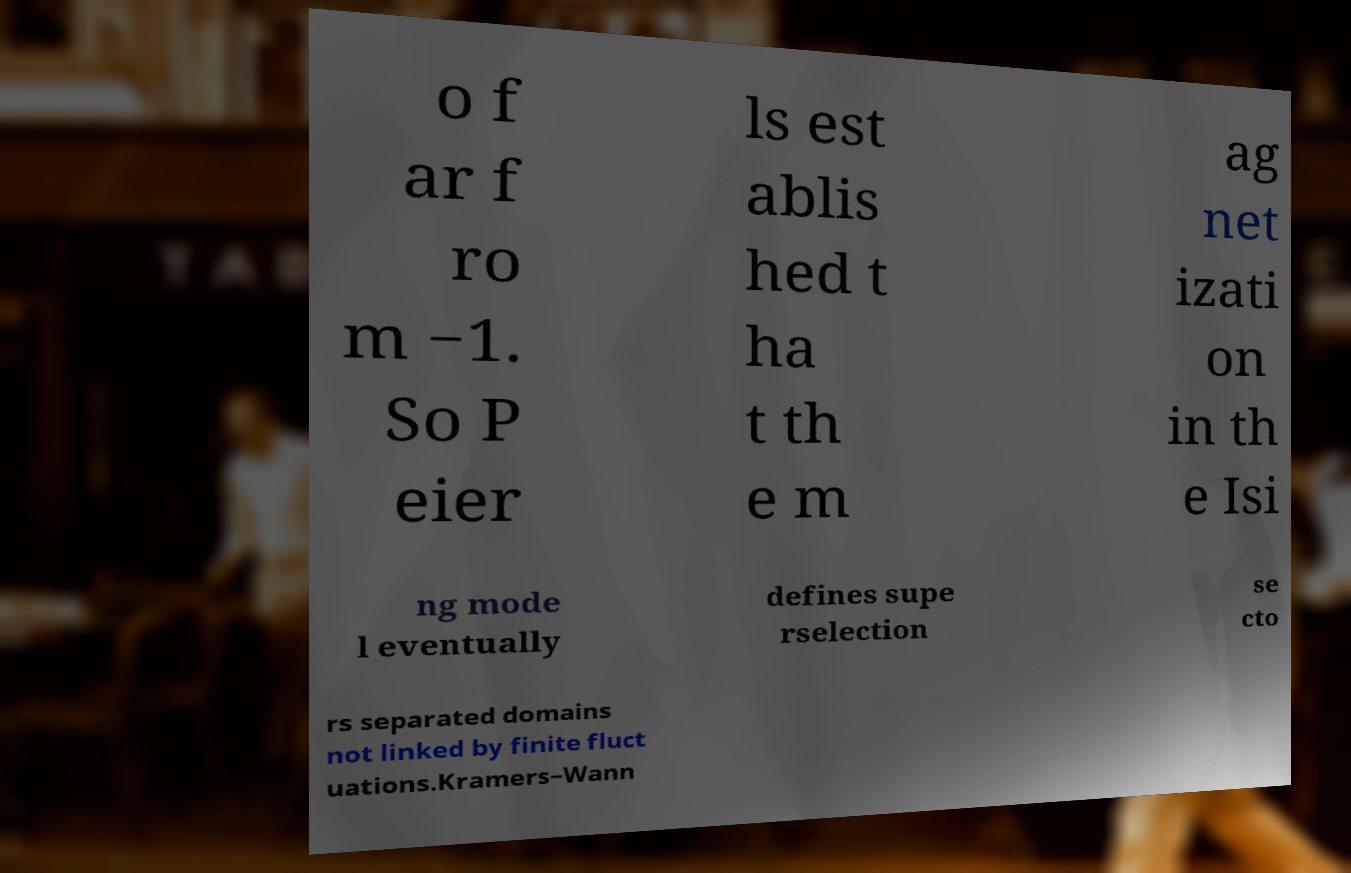I need the written content from this picture converted into text. Can you do that? o f ar f ro m −1. So P eier ls est ablis hed t ha t th e m ag net izati on in th e Isi ng mode l eventually defines supe rselection se cto rs separated domains not linked by finite fluct uations.Kramers–Wann 